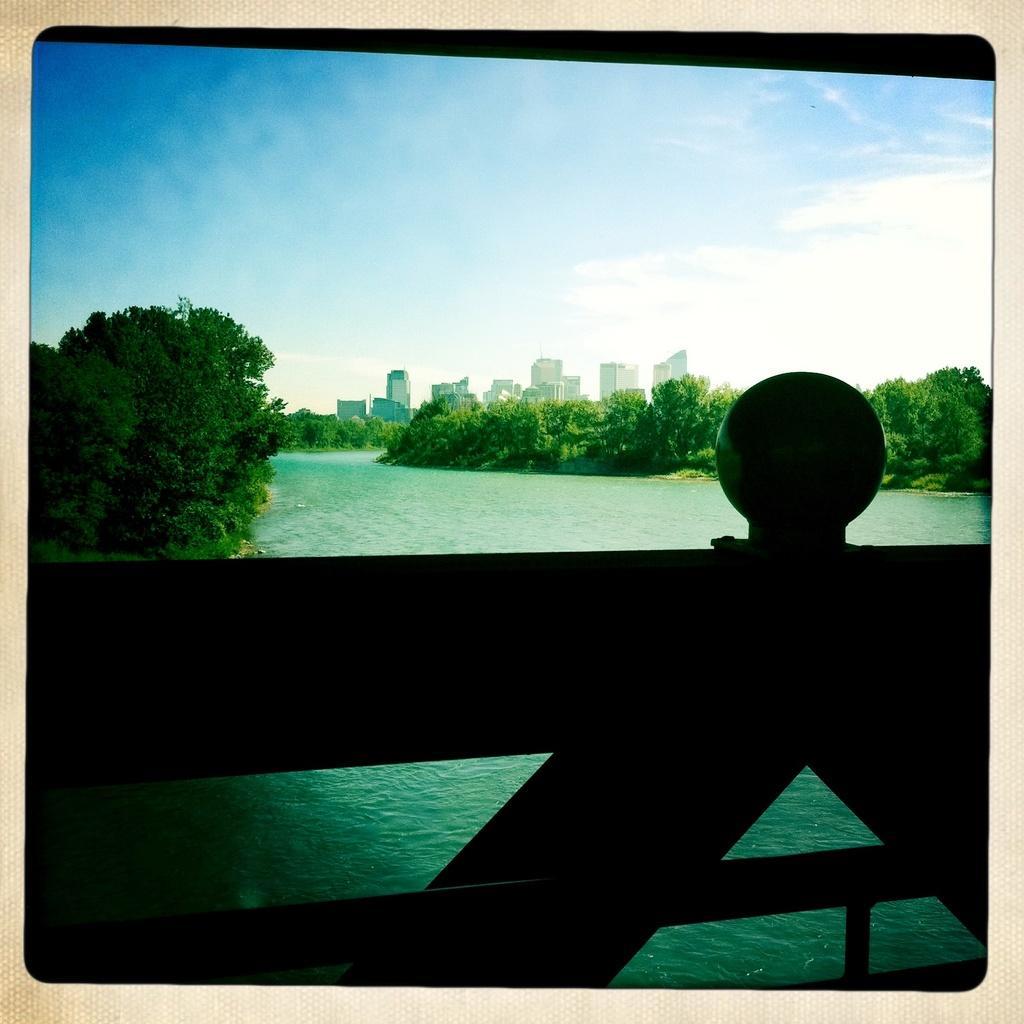Please provide a concise description of this image. In this image we can see buildings, sky with clouds, trees, water and bridge. 